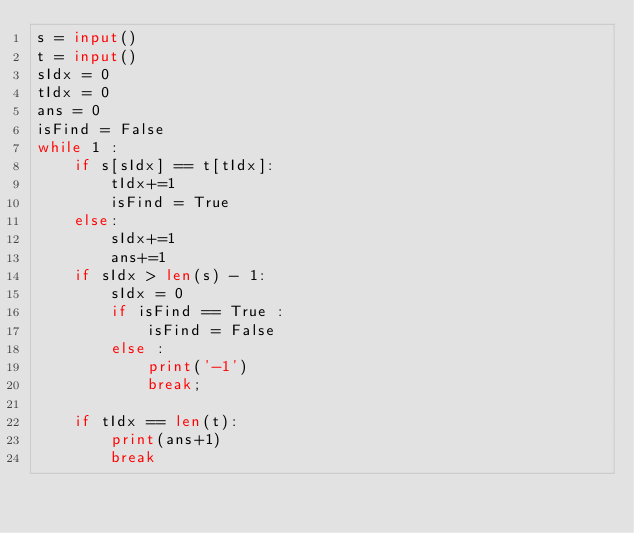<code> <loc_0><loc_0><loc_500><loc_500><_Python_>s = input()
t = input()
sIdx = 0
tIdx = 0
ans = 0
isFind = False
while 1 :
    if s[sIdx] == t[tIdx]:
        tIdx+=1
        isFind = True
    else:
        sIdx+=1
        ans+=1
    if sIdx > len(s) - 1:
        sIdx = 0
        if isFind == True :
            isFind = False
        else :
            print('-1')
            break;

    if tIdx == len(t):
        print(ans+1)
        break




</code> 